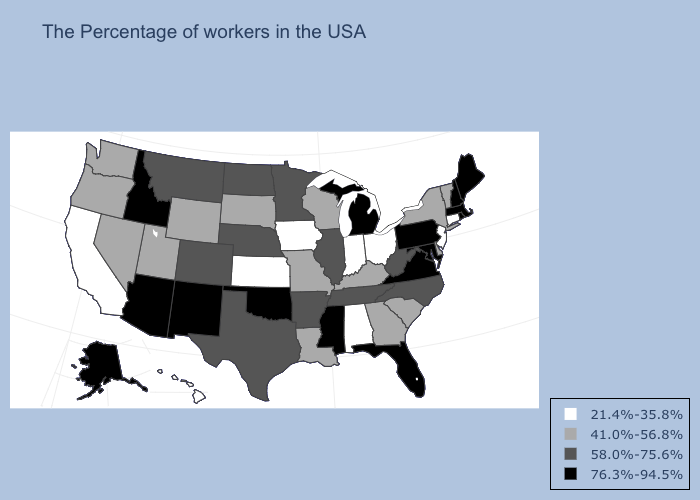What is the value of Pennsylvania?
Short answer required. 76.3%-94.5%. What is the value of Arkansas?
Keep it brief. 58.0%-75.6%. Does Utah have the same value as Idaho?
Keep it brief. No. Does Kansas have the same value as Delaware?
Write a very short answer. No. What is the highest value in the USA?
Quick response, please. 76.3%-94.5%. What is the lowest value in states that border Ohio?
Short answer required. 21.4%-35.8%. Among the states that border Maryland , does Virginia have the highest value?
Answer briefly. Yes. What is the value of South Carolina?
Give a very brief answer. 41.0%-56.8%. What is the value of Pennsylvania?
Short answer required. 76.3%-94.5%. Name the states that have a value in the range 41.0%-56.8%?
Short answer required. Vermont, New York, Delaware, South Carolina, Georgia, Kentucky, Wisconsin, Louisiana, Missouri, South Dakota, Wyoming, Utah, Nevada, Washington, Oregon. What is the value of Georgia?
Write a very short answer. 41.0%-56.8%. Which states have the lowest value in the USA?
Concise answer only. Connecticut, New Jersey, Ohio, Indiana, Alabama, Iowa, Kansas, California, Hawaii. What is the value of Vermont?
Write a very short answer. 41.0%-56.8%. What is the value of Ohio?
Concise answer only. 21.4%-35.8%. What is the value of Iowa?
Keep it brief. 21.4%-35.8%. 